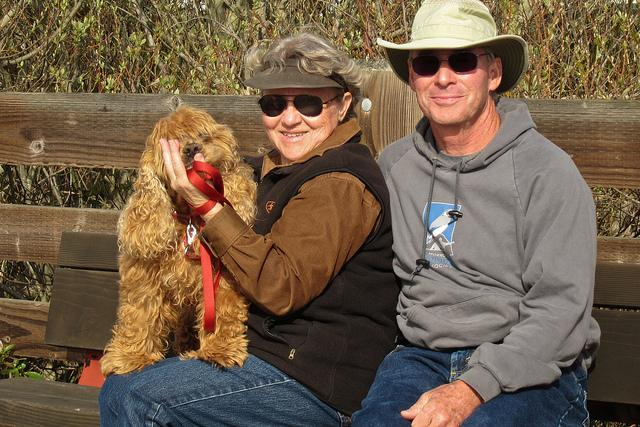What do both people have on? sunglasses 